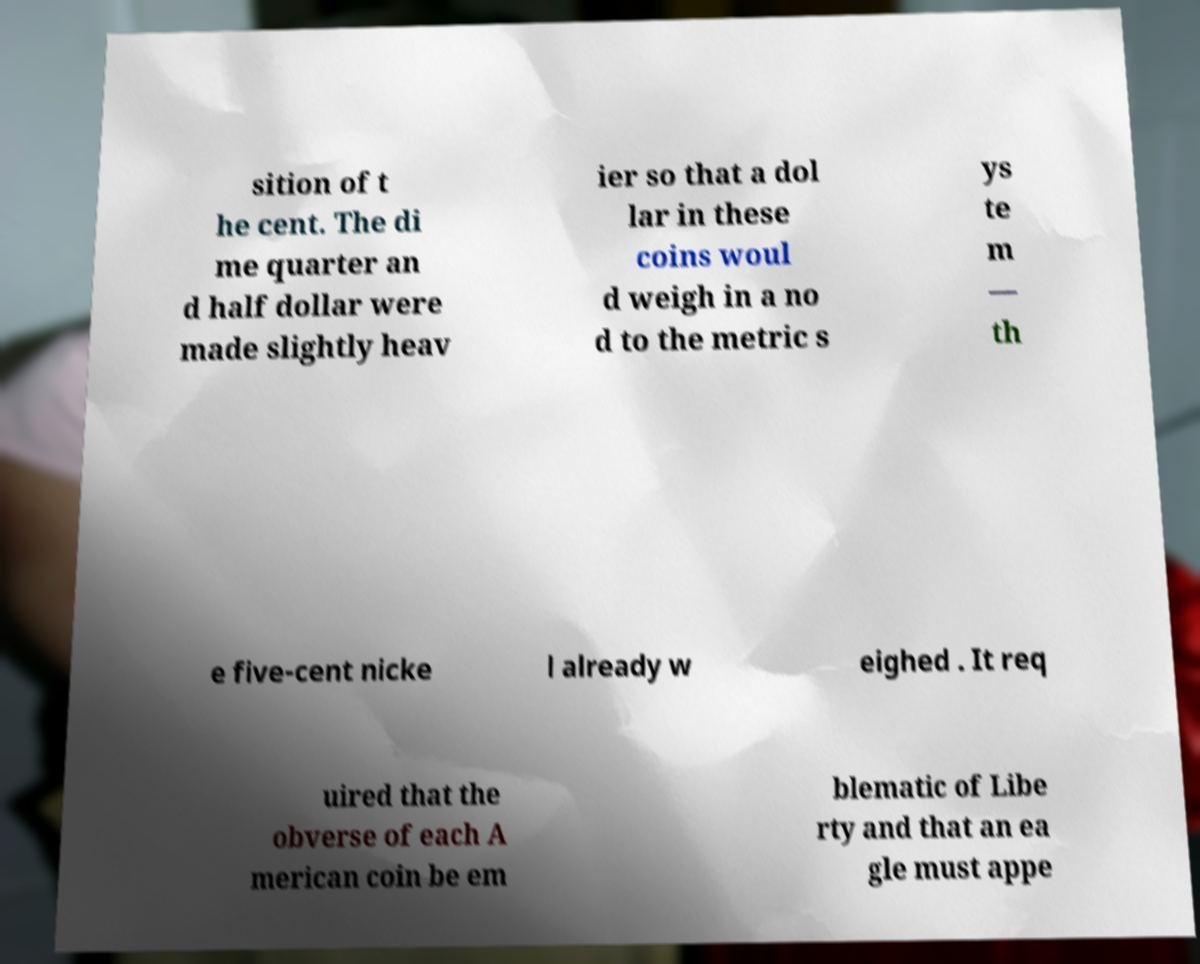Please read and relay the text visible in this image. What does it say? sition of t he cent. The di me quarter an d half dollar were made slightly heav ier so that a dol lar in these coins woul d weigh in a no d to the metric s ys te m — th e five-cent nicke l already w eighed . It req uired that the obverse of each A merican coin be em blematic of Libe rty and that an ea gle must appe 